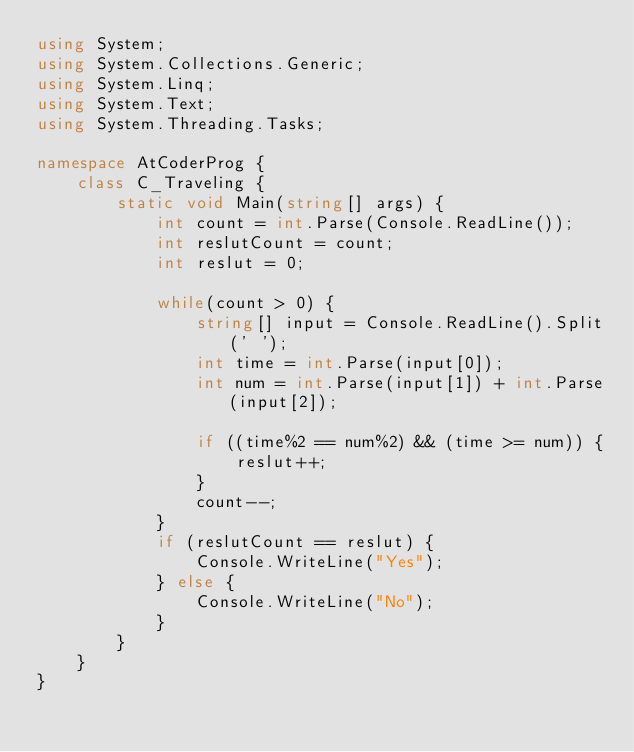<code> <loc_0><loc_0><loc_500><loc_500><_C#_>using System;
using System.Collections.Generic;
using System.Linq;
using System.Text;
using System.Threading.Tasks;

namespace AtCoderProg {
    class C_Traveling {
        static void Main(string[] args) {
            int count = int.Parse(Console.ReadLine());
            int reslutCount = count;
            int reslut = 0;

            while(count > 0) {
                string[] input = Console.ReadLine().Split(' ');
                int time = int.Parse(input[0]);
                int num = int.Parse(input[1]) + int.Parse(input[2]);

                if ((time%2 == num%2) && (time >= num)) {
                    reslut++;
                }
                count--;
            }
            if (reslutCount == reslut) {
                Console.WriteLine("Yes");
            } else {
                Console.WriteLine("No");
            }
        }
    }
}
</code> 